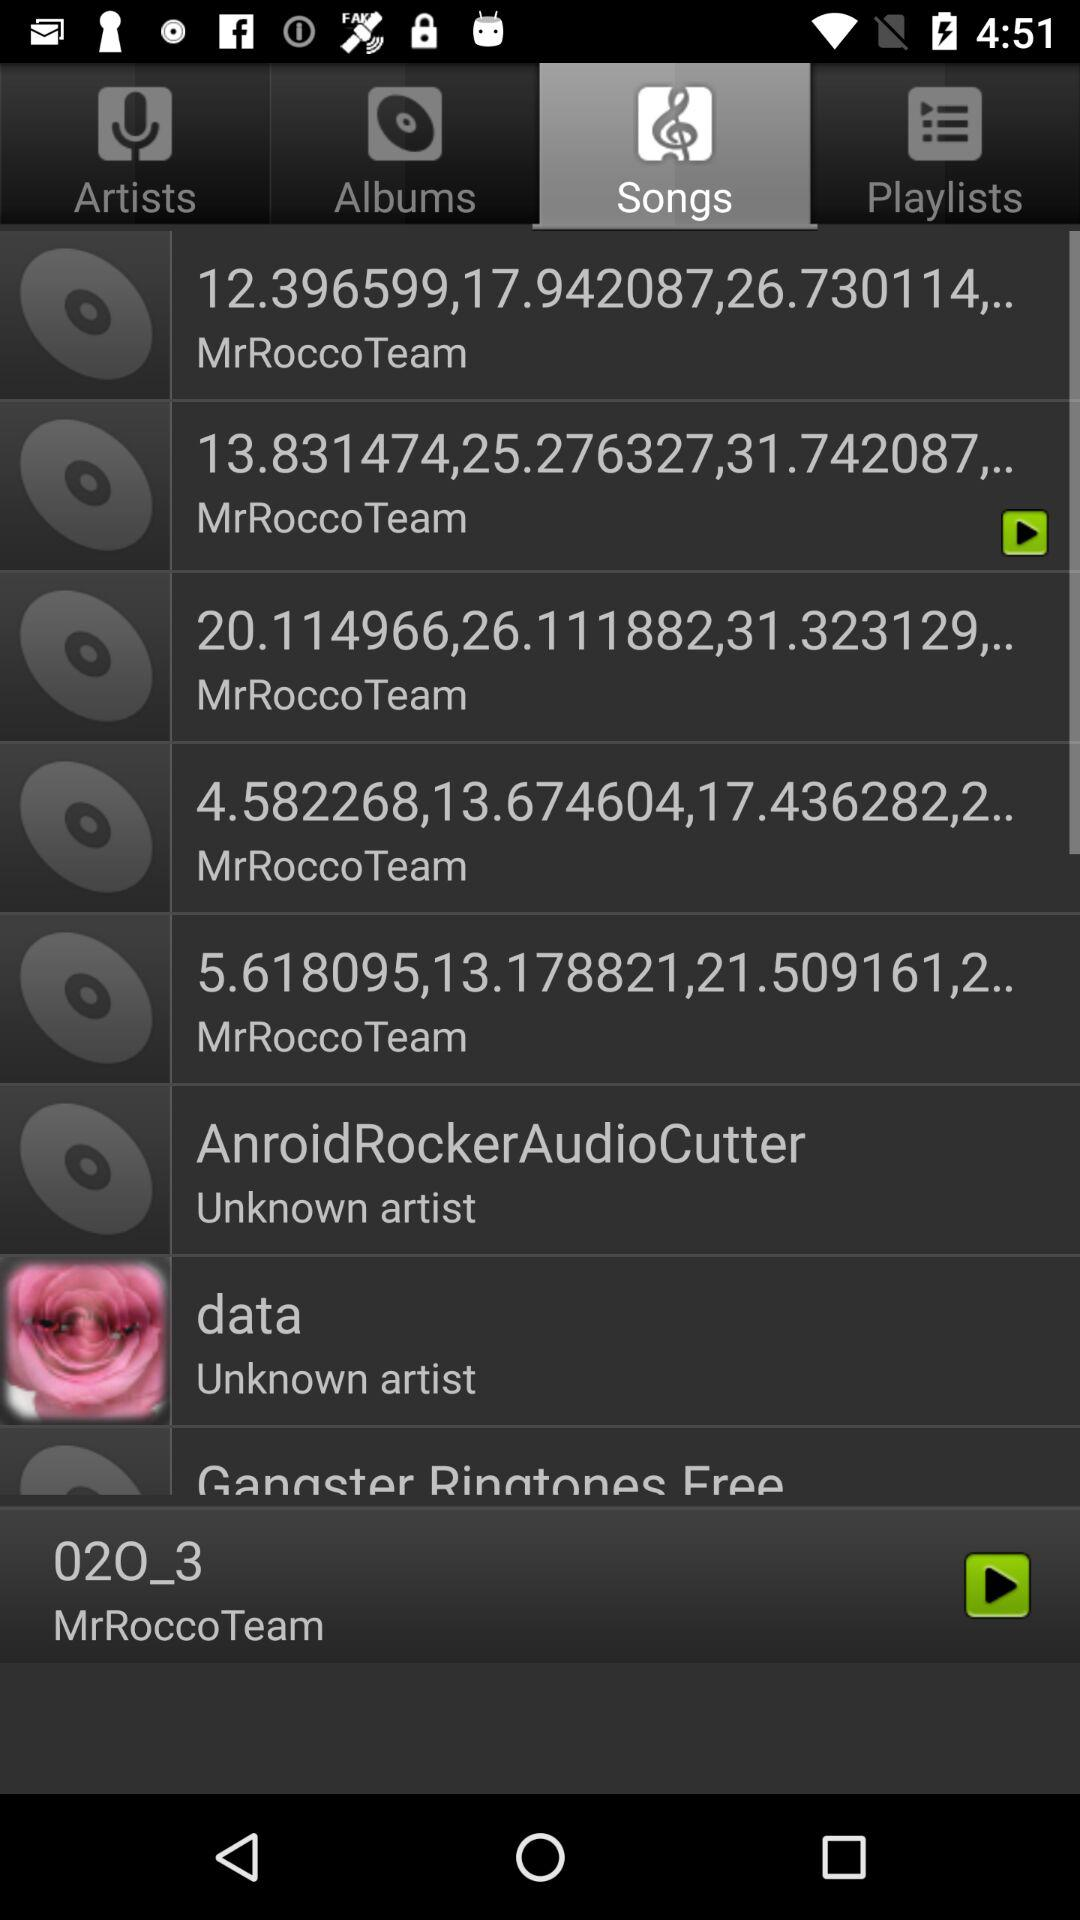How many songs have MrRocco Team as the artist?
Answer the question using a single word or phrase. 5 